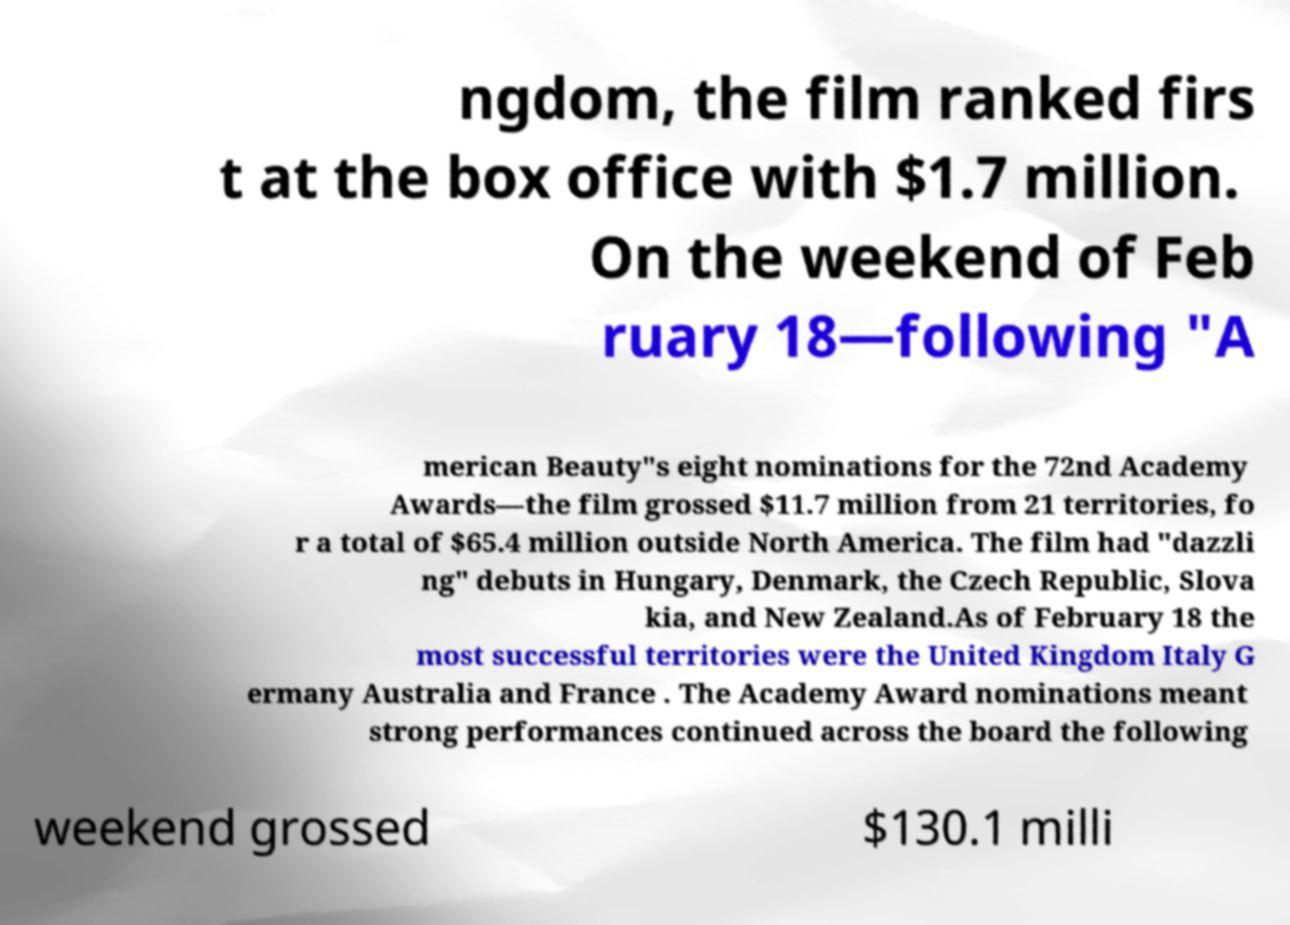Please identify and transcribe the text found in this image. ngdom, the film ranked firs t at the box office with $1.7 million. On the weekend of Feb ruary 18—following "A merican Beauty"s eight nominations for the 72nd Academy Awards—the film grossed $11.7 million from 21 territories, fo r a total of $65.4 million outside North America. The film had "dazzli ng" debuts in Hungary, Denmark, the Czech Republic, Slova kia, and New Zealand.As of February 18 the most successful territories were the United Kingdom Italy G ermany Australia and France . The Academy Award nominations meant strong performances continued across the board the following weekend grossed $130.1 milli 